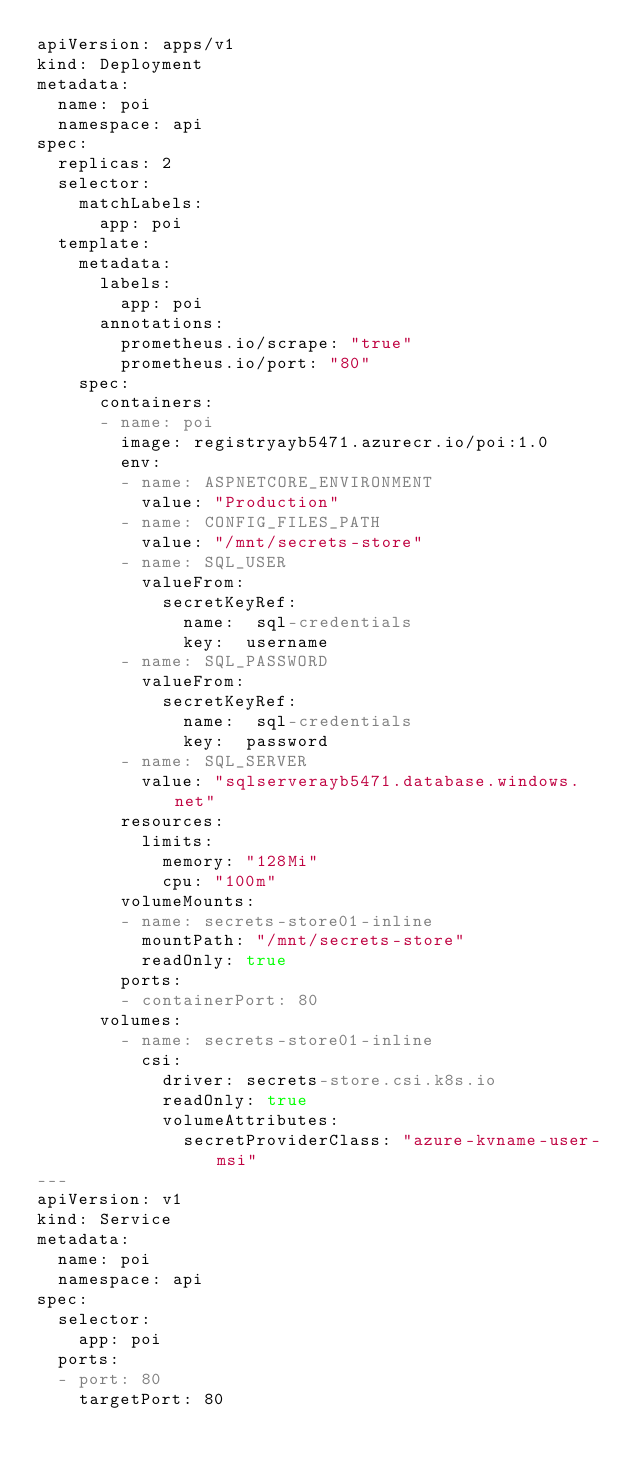Convert code to text. <code><loc_0><loc_0><loc_500><loc_500><_YAML_>apiVersion: apps/v1
kind: Deployment
metadata:
  name: poi
  namespace: api
spec:
  replicas: 2
  selector:
    matchLabels:
      app: poi
  template:
    metadata:
      labels:
        app: poi
      annotations:
        prometheus.io/scrape: "true"
        prometheus.io/port: "80"
    spec:
      containers:
      - name: poi
        image: registryayb5471.azurecr.io/poi:1.0
        env:
        - name: ASPNETCORE_ENVIRONMENT
          value: "Production"
        - name: CONFIG_FILES_PATH
          value: "/mnt/secrets-store"
        - name: SQL_USER
          valueFrom:
            secretKeyRef:
              name:  sql-credentials
              key:  username
        - name: SQL_PASSWORD
          valueFrom:
            secretKeyRef:
              name:  sql-credentials
              key:  password
        - name: SQL_SERVER
          value: "sqlserverayb5471.database.windows.net"
        resources:
          limits:
            memory: "128Mi"
            cpu: "100m"
        volumeMounts:
        - name: secrets-store01-inline
          mountPath: "/mnt/secrets-store"
          readOnly: true
        ports:
        - containerPort: 80
      volumes:
        - name: secrets-store01-inline
          csi:
            driver: secrets-store.csi.k8s.io
            readOnly: true
            volumeAttributes:
              secretProviderClass: "azure-kvname-user-msi"
---
apiVersion: v1
kind: Service
metadata:
  name: poi
  namespace: api
spec:
  selector:
    app: poi
  ports:
  - port: 80
    targetPort: 80
    </code> 